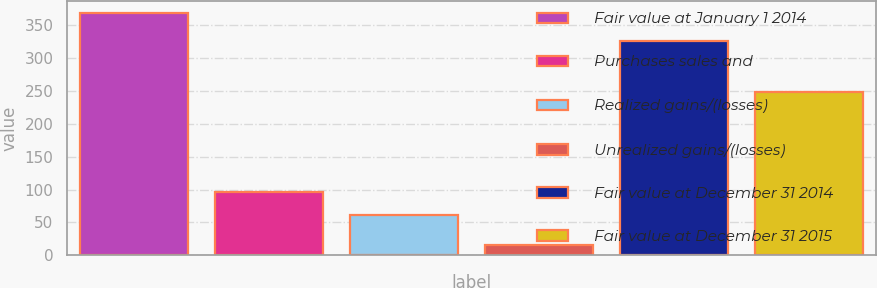<chart> <loc_0><loc_0><loc_500><loc_500><bar_chart><fcel>Fair value at January 1 2014<fcel>Purchases sales and<fcel>Realized gains/(losses)<fcel>Unrealized gains/(losses)<fcel>Fair value at December 31 2014<fcel>Fair value at December 31 2015<nl><fcel>369<fcel>96.4<fcel>61<fcel>15<fcel>327<fcel>249<nl></chart> 